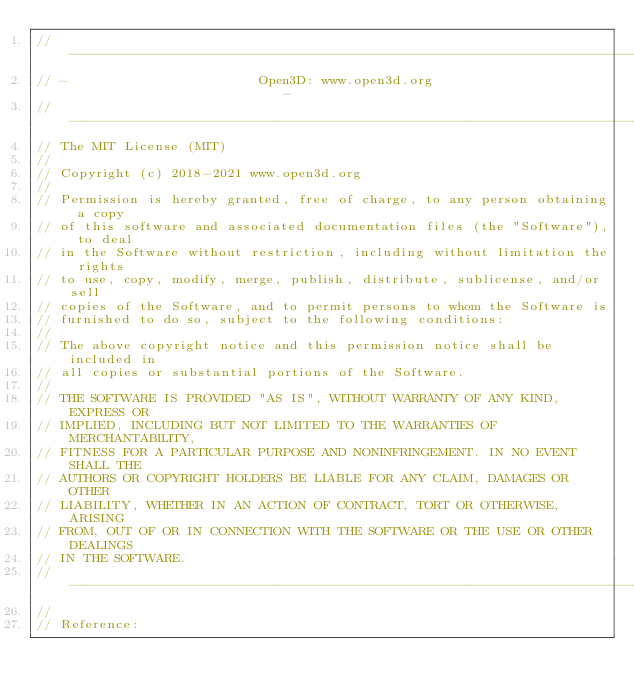<code> <loc_0><loc_0><loc_500><loc_500><_Cuda_>// ----------------------------------------------------------------------------
// -                        Open3D: www.open3d.org                            -
// ----------------------------------------------------------------------------
// The MIT License (MIT)
//
// Copyright (c) 2018-2021 www.open3d.org
//
// Permission is hereby granted, free of charge, to any person obtaining a copy
// of this software and associated documentation files (the "Software"), to deal
// in the Software without restriction, including without limitation the rights
// to use, copy, modify, merge, publish, distribute, sublicense, and/or sell
// copies of the Software, and to permit persons to whom the Software is
// furnished to do so, subject to the following conditions:
//
// The above copyright notice and this permission notice shall be included in
// all copies or substantial portions of the Software.
//
// THE SOFTWARE IS PROVIDED "AS IS", WITHOUT WARRANTY OF ANY KIND, EXPRESS OR
// IMPLIED, INCLUDING BUT NOT LIMITED TO THE WARRANTIES OF MERCHANTABILITY,
// FITNESS FOR A PARTICULAR PURPOSE AND NONINFRINGEMENT. IN NO EVENT SHALL THE
// AUTHORS OR COPYRIGHT HOLDERS BE LIABLE FOR ANY CLAIM, DAMAGES OR OTHER
// LIABILITY, WHETHER IN AN ACTION OF CONTRACT, TORT OR OTHERWISE, ARISING
// FROM, OUT OF OR IN CONNECTION WITH THE SOFTWARE OR THE USE OR OTHER DEALINGS
// IN THE SOFTWARE.
// ----------------------------------------------------------------------------
//
// Reference:</code> 